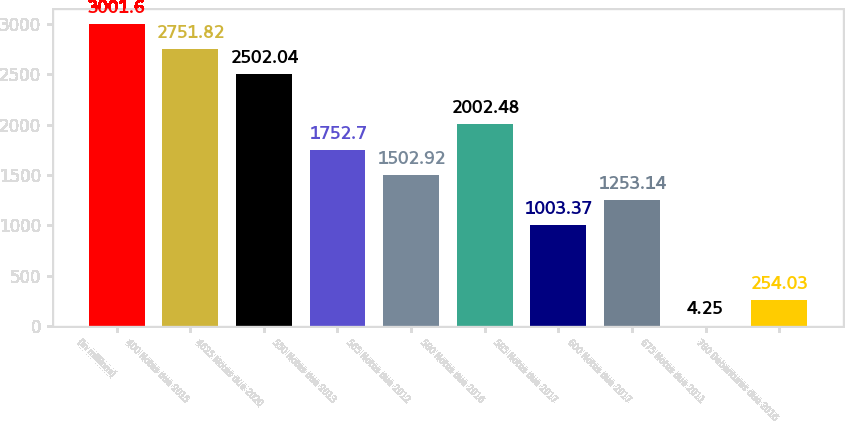Convert chart to OTSL. <chart><loc_0><loc_0><loc_500><loc_500><bar_chart><fcel>(in millions)<fcel>400 Notes due 2015<fcel>4625 Notes due 2020<fcel>550 Notes due 2013<fcel>565 Notes due 2012<fcel>580 Notes due 2016<fcel>585 Notes due 2017<fcel>600 Notes due 2017<fcel>675 Notes due 2011<fcel>780 Debentures due 2016<nl><fcel>3001.6<fcel>2751.82<fcel>2502.04<fcel>1752.7<fcel>1502.92<fcel>2002.48<fcel>1003.37<fcel>1253.14<fcel>4.25<fcel>254.03<nl></chart> 